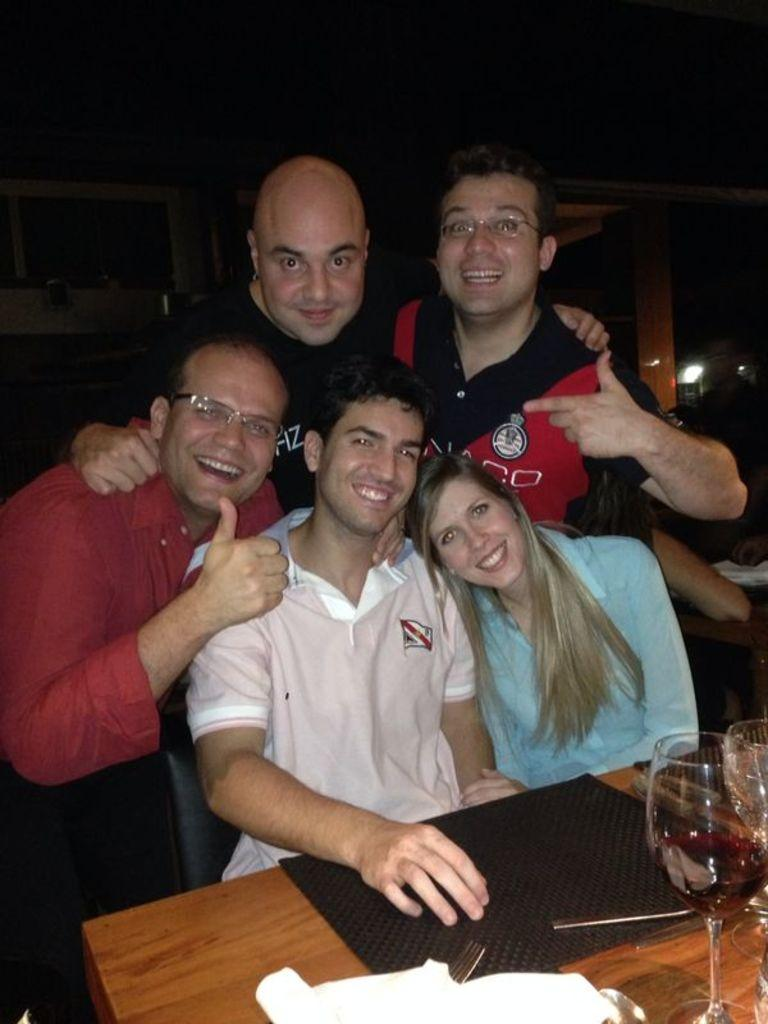What are the people in the image doing? The people in the image are sitting and standing. What object can be seen in the image that is typically used for eating or working on? There is a table in the image. What is placed on the table? There is a mat and glasses on the table. What type of ticket is visible on the table in the image? There is no ticket present on the table in the image. What belief system is represented by the people in the image? The image does not provide any information about the beliefs of the people in the image. 